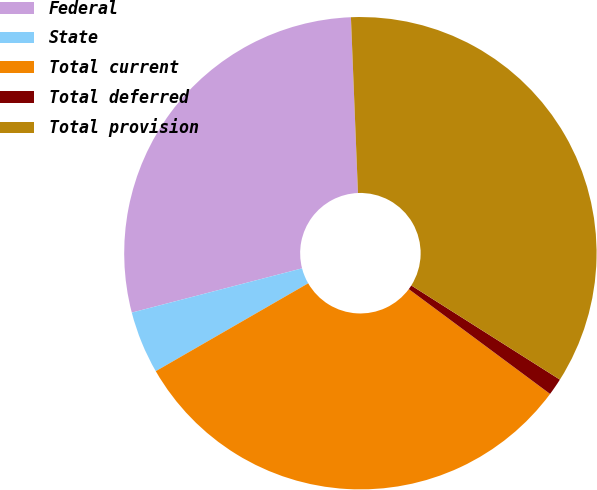Convert chart to OTSL. <chart><loc_0><loc_0><loc_500><loc_500><pie_chart><fcel>Federal<fcel>State<fcel>Total current<fcel>Total deferred<fcel>Total provision<nl><fcel>28.41%<fcel>4.28%<fcel>31.52%<fcel>1.17%<fcel>34.63%<nl></chart> 